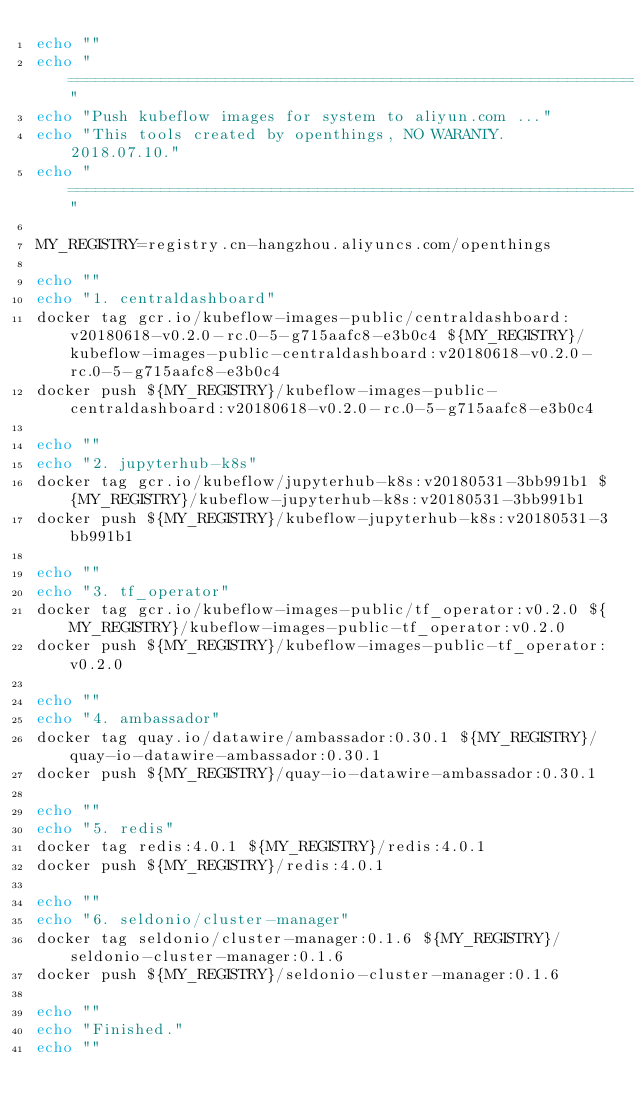<code> <loc_0><loc_0><loc_500><loc_500><_Bash_>echo ""
echo "================================================================="
echo "Push kubeflow images for system to aliyun.com ..."
echo "This tools created by openthings, NO WARANTY. 2018.07.10."
echo "================================================================="

MY_REGISTRY=registry.cn-hangzhou.aliyuncs.com/openthings

echo ""
echo "1. centraldashboard"
docker tag gcr.io/kubeflow-images-public/centraldashboard:v20180618-v0.2.0-rc.0-5-g715aafc8-e3b0c4 ${MY_REGISTRY}/kubeflow-images-public-centraldashboard:v20180618-v0.2.0-rc.0-5-g715aafc8-e3b0c4
docker push ${MY_REGISTRY}/kubeflow-images-public-centraldashboard:v20180618-v0.2.0-rc.0-5-g715aafc8-e3b0c4

echo ""
echo "2. jupyterhub-k8s"
docker tag gcr.io/kubeflow/jupyterhub-k8s:v20180531-3bb991b1 ${MY_REGISTRY}/kubeflow-jupyterhub-k8s:v20180531-3bb991b1
docker push ${MY_REGISTRY}/kubeflow-jupyterhub-k8s:v20180531-3bb991b1

echo ""
echo "3. tf_operator"
docker tag gcr.io/kubeflow-images-public/tf_operator:v0.2.0 ${MY_REGISTRY}/kubeflow-images-public-tf_operator:v0.2.0
docker push ${MY_REGISTRY}/kubeflow-images-public-tf_operator:v0.2.0

echo ""
echo "4. ambassador"
docker tag quay.io/datawire/ambassador:0.30.1 ${MY_REGISTRY}/quay-io-datawire-ambassador:0.30.1
docker push ${MY_REGISTRY}/quay-io-datawire-ambassador:0.30.1

echo ""
echo "5. redis"
docker tag redis:4.0.1 ${MY_REGISTRY}/redis:4.0.1
docker push ${MY_REGISTRY}/redis:4.0.1

echo ""
echo "6. seldonio/cluster-manager"
docker tag seldonio/cluster-manager:0.1.6 ${MY_REGISTRY}/seldonio-cluster-manager:0.1.6
docker push ${MY_REGISTRY}/seldonio-cluster-manager:0.1.6

echo ""
echo "Finished."
echo ""
</code> 